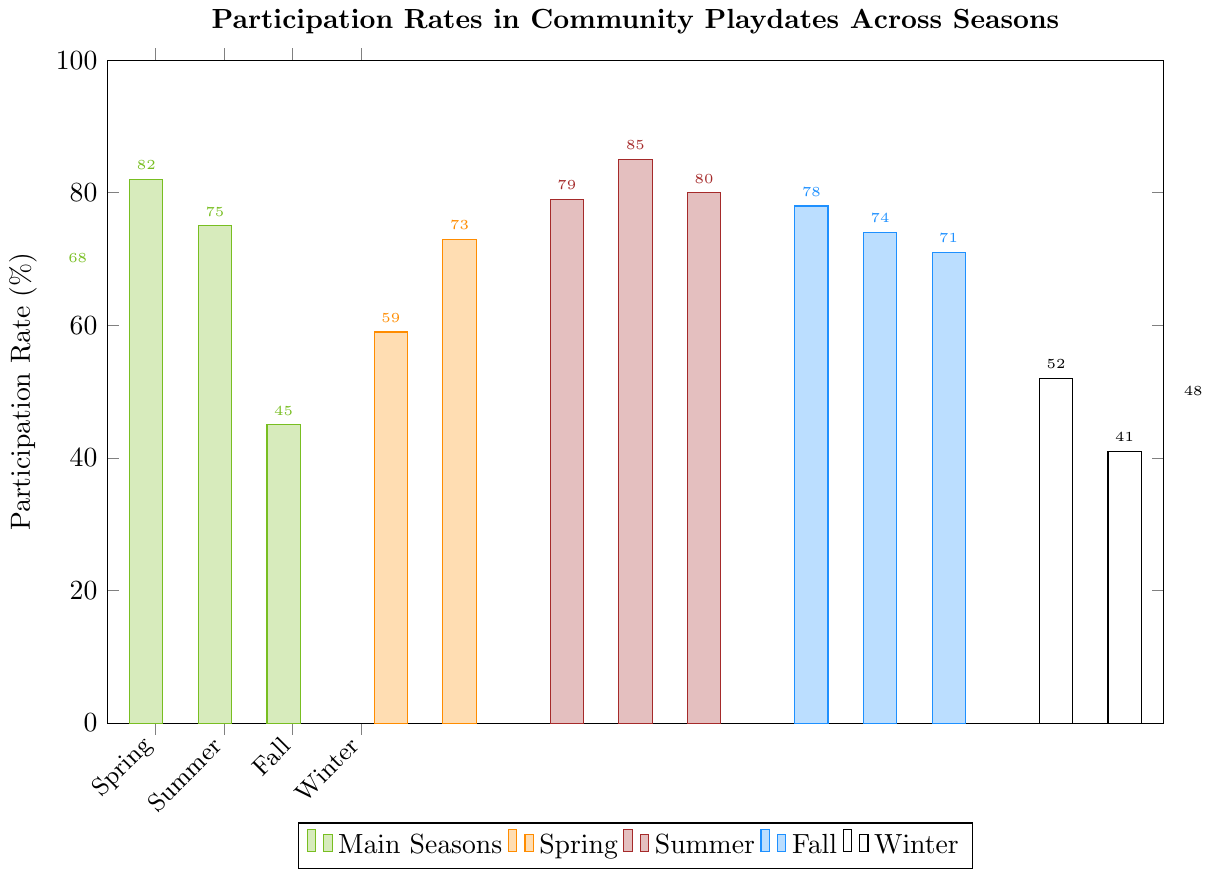Which season has the highest participation rate? The highest bar on the chart represents the season with the highest participation rate. This corresponds to Mid Summer with a participation rate of 85%.
Answer: Mid Summer What's the difference in participation rates between Early Winter and Mid Winter? To find the difference, subtract the participation rate of Mid Winter (41%) from that of Early Winter (52%). The difference is 52% - 41% = 11%.
Answer: 11% Which period has a higher participation rate: Late Spring or Late Fall? Compare the heights of the bars for Late Spring (73%) and Late Fall (71%). Late Spring has a higher participation rate by 2 percentage points.
Answer: Late Spring What is the average participation rate for the three periods in Winter? Add the participation rates for Early Winter (52%), Mid Winter (41%), and Late Winter (48%) and then divide by 3. The average is (52 + 41 + 48) / 3 = 47%.
Answer: 47% How does the participation rate in Fall compare to that in Spring? The participation rate in Fall (75%) is higher than in Spring (68%) by 7 percentage points.
Answer: Fall What is the total participation rate for all Spring periods? Add the participation rates for Spring (68%), Early Spring (59%), and Late Spring (73%). The total is 68 + 59 + 73 = 200%.
Answer: 200% Which period within Summer has the highest participation rate, and what is it? Among Early Summer (79%), Mid Summer (85%), and Late Summer (80%), Mid Summer has the highest participation rate of 85%.
Answer: Mid Summer, 85% Is Winter consistently the season with the lowest participation rates? Yes, Winter periods (Early Winter: 52%, Mid Winter: 41%, Late Winter: 48%) have consistently lower participation rates compared to periods in other seasons.
Answer: Yes What's the range of participation rates in Fall? The range is calculated as the difference between the highest (Early Fall, 78%) and the lowest (Late Fall, 71%) participation rates within Fall. The range is 78% - 71% = 7%.
Answer: 7% What is the participation rate trend across the main Winter season? Plot the participation rates for Early Winter (52%), Mid Winter (41%), and Late Winter (48%) in order. The trend shows a dip from Early to Mid Winter and a slight rise from Mid to Late Winter.
Answer: Early to mid decreases, mid to late increases 